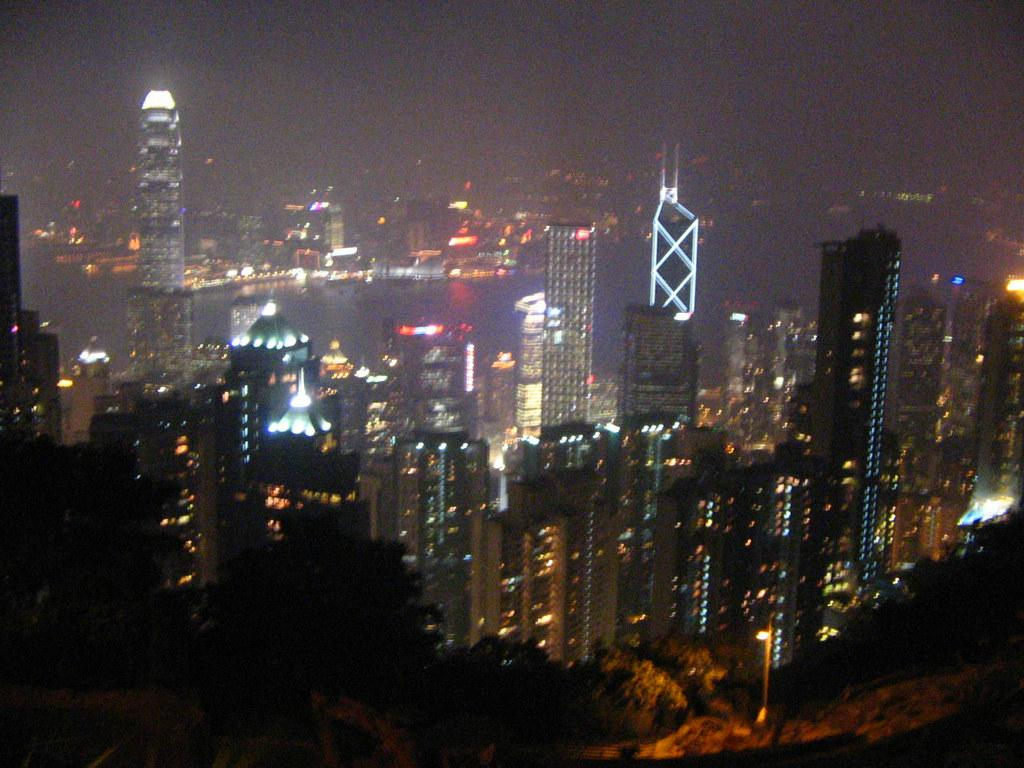What type of structures can be seen in the image? There are buildings in the image. What natural elements are present in the image? There are trees in the image. What artificial elements are present in the image? There are lights in the image. What type of landscape feature can be seen in the image? There is water visible in the image. What else can be seen in the image besides the mentioned elements? There are objects in the image. How would you describe the overall appearance of the image? The background of the image is dark. What type of creature is holding the string in the image? There is no creature holding a string in the image. What type of system is responsible for the lighting in the image? The image does not provide information about the lighting system. 